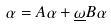<formula> <loc_0><loc_0><loc_500><loc_500>\alpha = A \alpha + \underline { \omega } B \alpha</formula> 